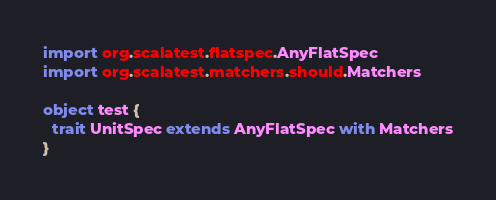<code> <loc_0><loc_0><loc_500><loc_500><_Scala_>
import org.scalatest.flatspec.AnyFlatSpec
import org.scalatest.matchers.should.Matchers

object test {
  trait UnitSpec extends AnyFlatSpec with Matchers
}
</code> 